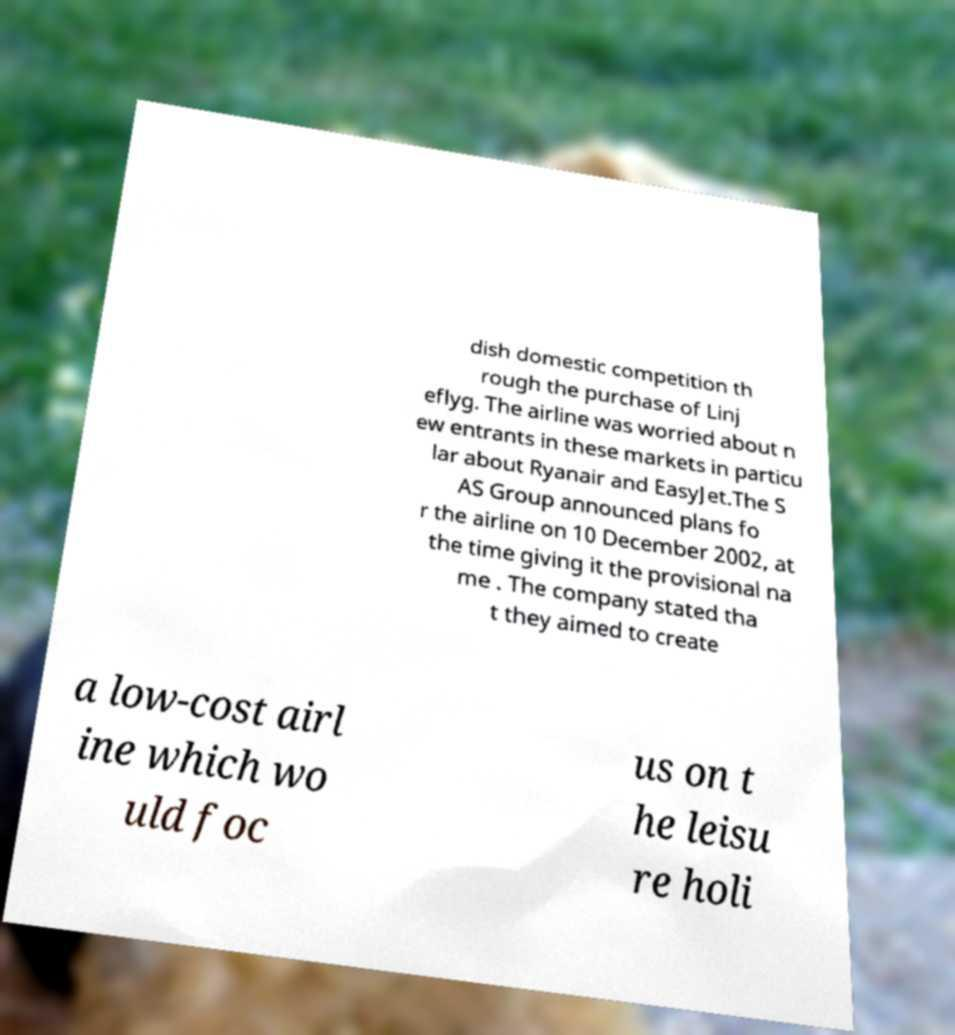Please identify and transcribe the text found in this image. dish domestic competition th rough the purchase of Linj eflyg. The airline was worried about n ew entrants in these markets in particu lar about Ryanair and EasyJet.The S AS Group announced plans fo r the airline on 10 December 2002, at the time giving it the provisional na me . The company stated tha t they aimed to create a low-cost airl ine which wo uld foc us on t he leisu re holi 